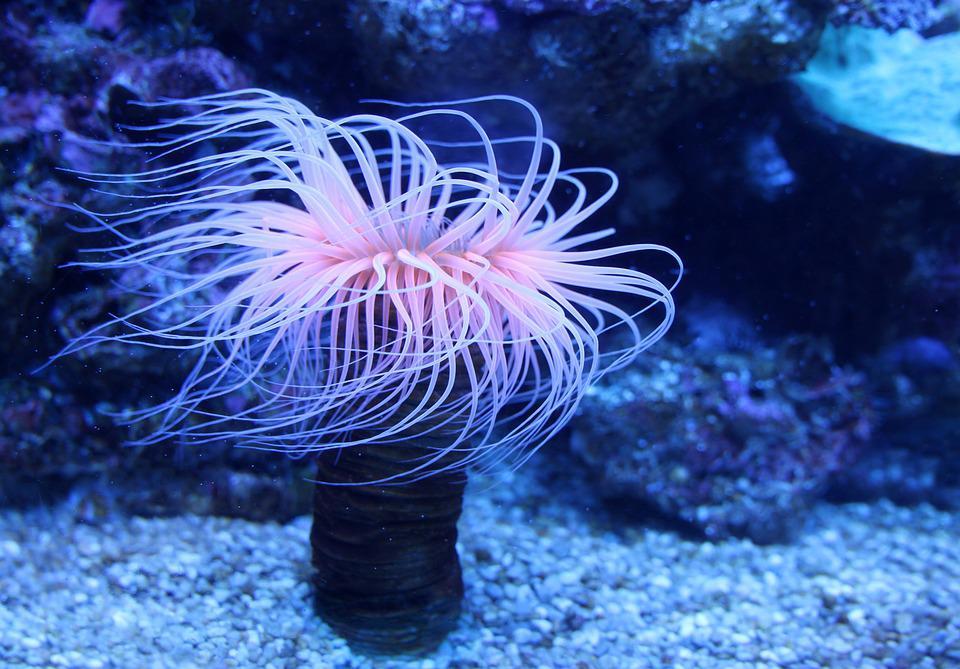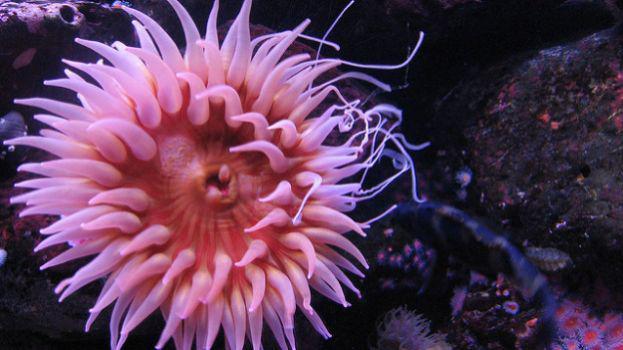The first image is the image on the left, the second image is the image on the right. For the images shown, is this caption "One image feature a clown fish next to a sea anemone" true? Answer yes or no. No. The first image is the image on the left, the second image is the image on the right. For the images displayed, is the sentence "In at least one image there is a single orange and white cloud fish swimming above a single coral." factually correct? Answer yes or no. No. 